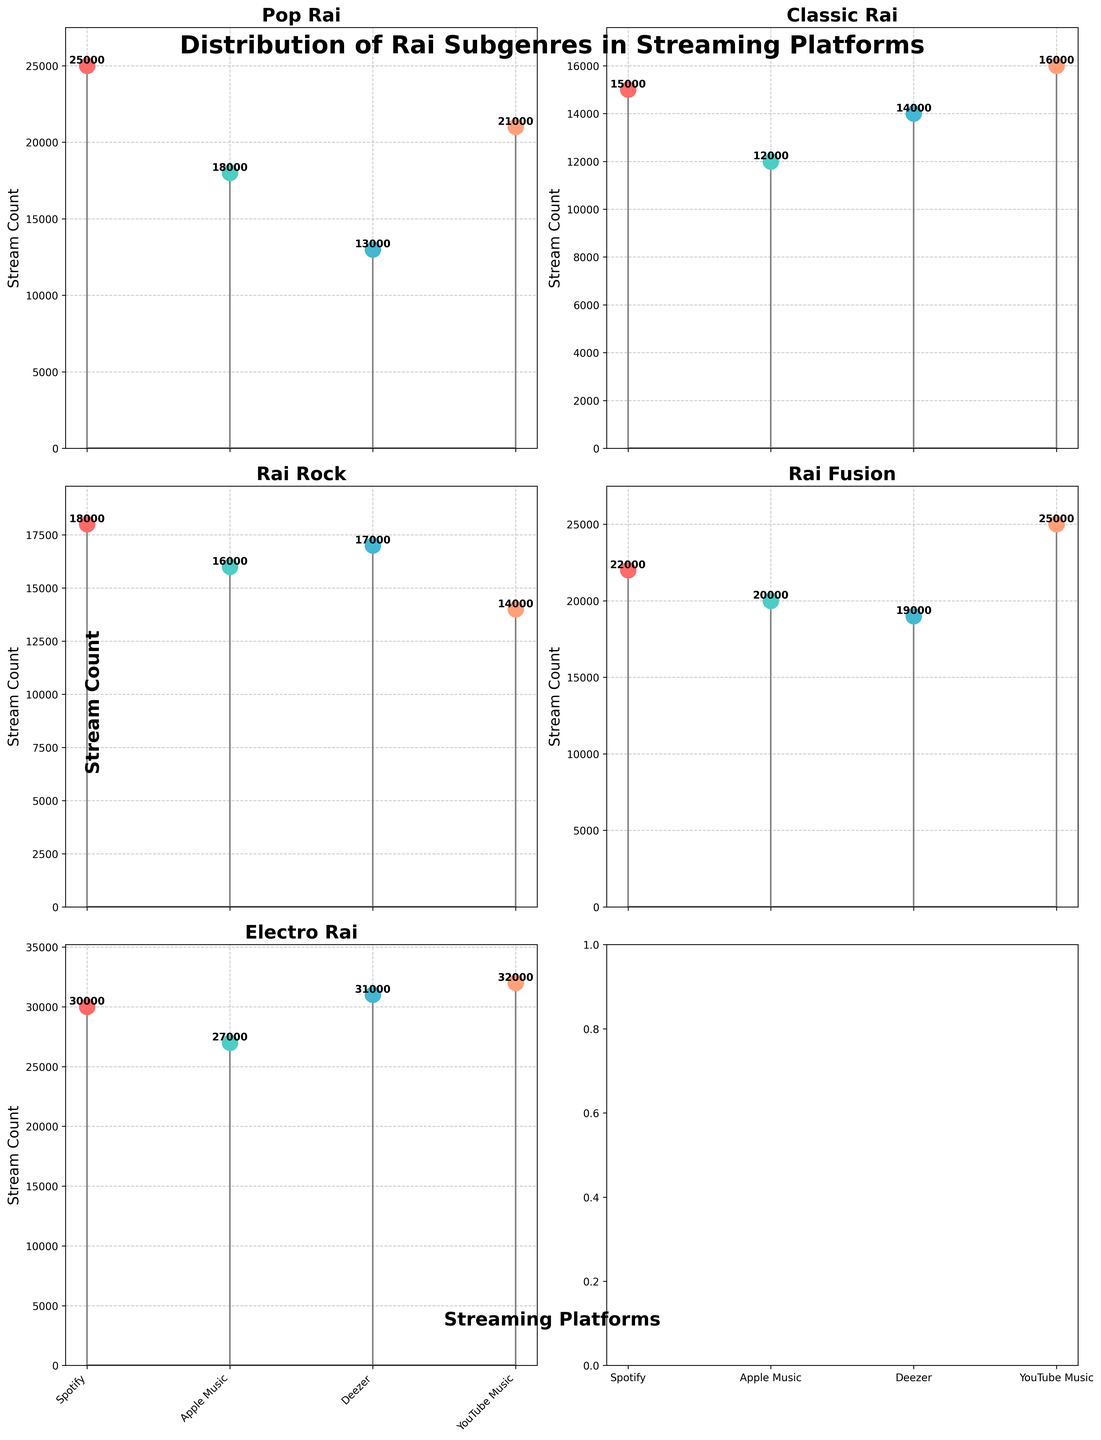How many subgenres of Rai are visualized in the figure? Refer to the titles of each subplot, they list the different subgenres. The titles are 'Pop Rai', 'Classic Rai', 'Rai Rock', 'Rai Fusion', and 'Electro Rai'. Count these to find the number of subgenres.
Answer: 5 What subgenre has the highest stream count on Deezer? Look at the stem plot for each subgenre and identify the highest value for Deezer. 'Electro Rai' has the highest stream count, which is 31,000.
Answer: Electro Rai Which platform has the highest total stream count for 'Rai Fusion'? Sum the stream counts of 'Rai Fusion' across all platforms. YouTube Music has 25,000, Spotify has 22,000, Apple Music has 20,000, and Deezer has 19,000. YouTube Music has the highest stream count.
Answer: YouTube Music What's the approximate difference in stream count between the two most popular platforms for 'Electro Rai'? The two most popular platforms for 'Electro Rai' are YouTube Music (32,000) and Deezer (31,000). The difference is 32,000 - 31,000.
Answer: 1,000 Which subgenre has the lowest stream count on Spotify and how much is it? Compare the stream counts for each subgenre on Spotify. 'Classic Rai' has the lowest stream count with 15,000 streams.
Answer: Classic Rai, 15,000 What is the average stream count for 'Pop Rai' across all platforms? Sum the stream counts for 'Pop Rai' (25,000 + 18,000 + 13,000 + 21,000) and divide by the number of platforms (4). The average is (25,000 + 18,000 + 13,000 + 21,000) / 4.
Answer: 19,250 How does the stream count for 'Rai Rock' on Apple Music compare to Spotify? Compare the stream counts for 'Rai Rock' on Apple Music and Spotify. Apple Music has 16,000 streams, and Spotify has 18,000 streams. Spotify has more streams.
Answer: Spotify has more Which subgenre has the most balanced stream counts across all platforms? Examine the variance in stream counts for each subgenre across the platforms. 'Rai Rock' has stream counts of 18,000, 16,000, 17,000, and 14,000, which are quite balanced.
Answer: Rai Rock What's the total stream count for 'Classic Rai' combining all platforms? Add the stream counts for 'Classic Rai' across all platforms: 15,000 (Spotify) + 12,000 (Apple Music) + 14,000 (Deezer) + 16,000 (YouTube Music).
Answer: 57,000 